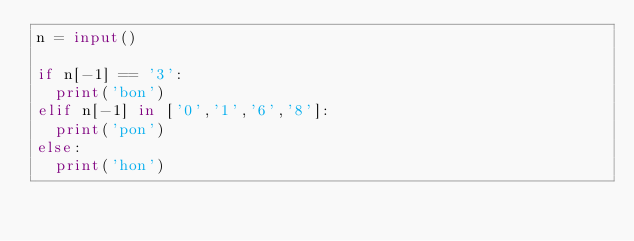<code> <loc_0><loc_0><loc_500><loc_500><_Python_>n = input()

if n[-1] == '3':
  print('bon')
elif n[-1] in ['0','1','6','8']:
  print('pon')
else:
  print('hon')
</code> 